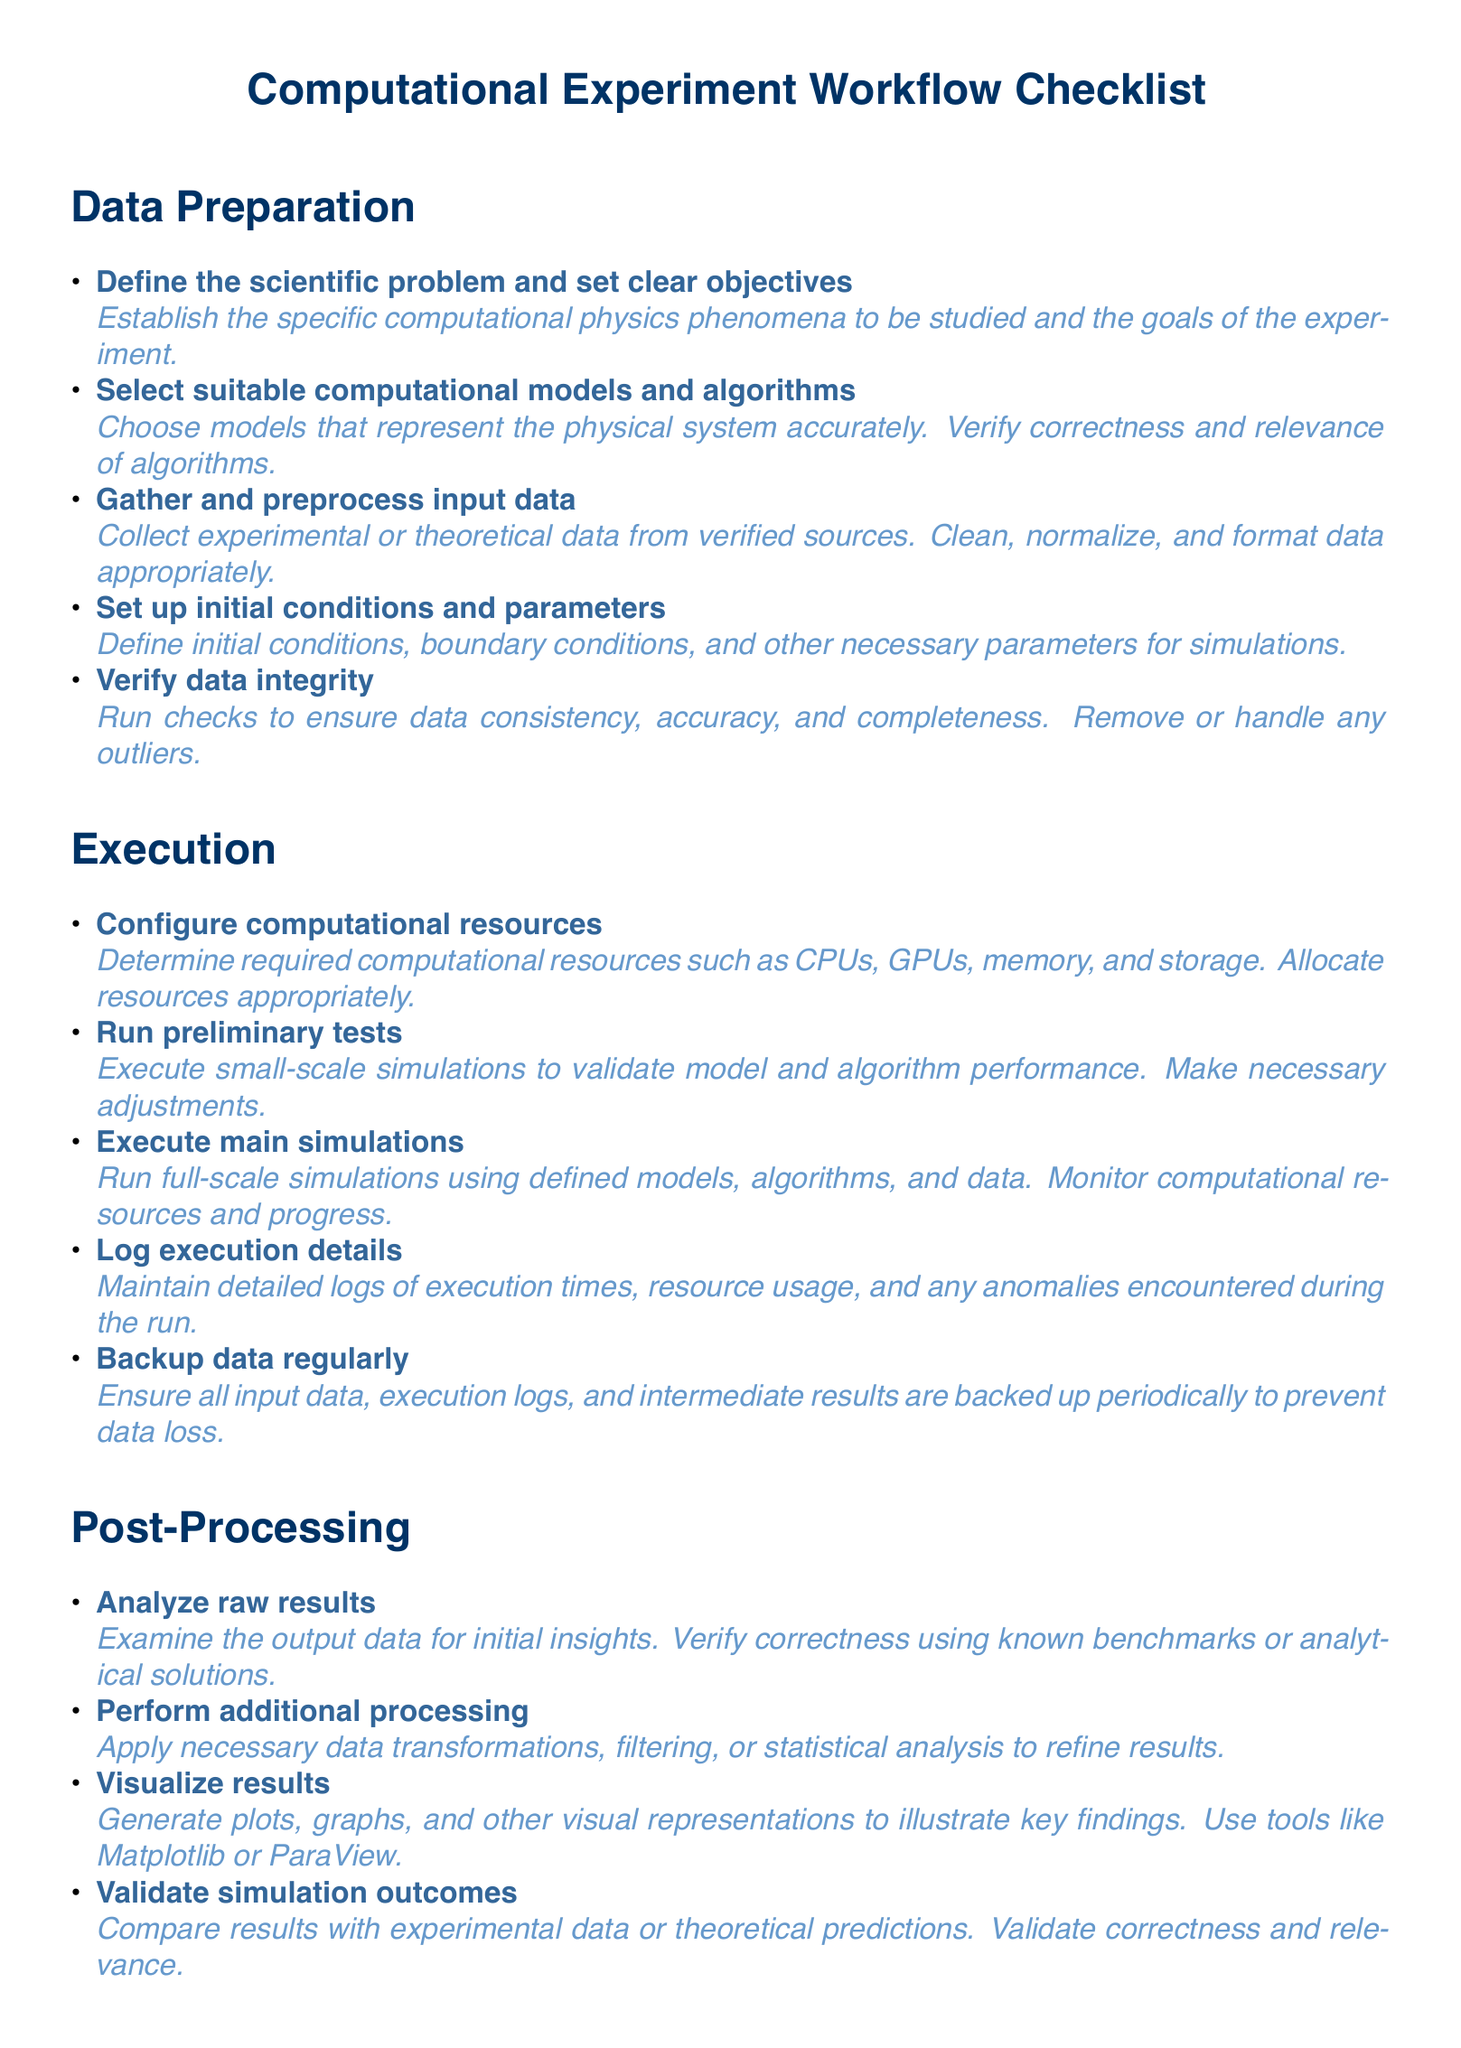What is the first step in the Data Preparation section? The first step listed in the Data Preparation section is to define the scientific problem and set clear objectives.
Answer: Define the scientific problem and set clear objectives How many items are listed under the Execution section? There are five items listed under the Execution section.
Answer: Five What is described in the item about backing up data? The item describes the importance of backing up all input data, execution logs, and intermediate results to prevent data loss.
Answer: Ensure all input data, execution logs, and intermediate results are backed up periodically What action is recommended for initial insights after analyzing raw results? After analyzing raw results, it is recommended to verify correctness using known benchmarks or analytical solutions.
Answer: Verify correctness using known benchmarks or analytical solutions What is the purpose of visualizing results? The purpose of visualizing results is to generate plots, graphs, and other visual representations to illustrate key findings.
Answer: Generate plots, graphs, and other visual representations to illustrate key findings What is the final item listed in the Post-Processing section? The final item listed in the Post-Processing section is to archive data and code.
Answer: Archive data and code 